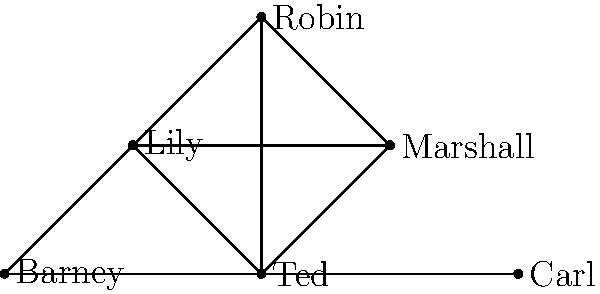In this network diagram representing character connections in "How I Met Your Mother," which character has the highest degree centrality (most direct connections)? To determine the character with the highest degree centrality, we need to count the number of direct connections (edges) for each character:

1. Ted: Connected to Marshall, Lily, Robin, Barney, and Carl (5 connections)
2. Marshall: Connected to Ted, Lily, and Robin (3 connections)
3. Lily: Connected to Ted, Marshall, and Robin (3 connections)
4. Robin: Connected to Ted, Marshall, Lily, and Barney (4 connections)
5. Barney: Connected to Ted, Robin, and Carl (3 connections)
6. Carl: Connected to Ted and Barney (2 connections)

By counting the number of edges connected to each node, we can see that Ted has the highest number of direct connections with 5 edges.
Answer: Ted 